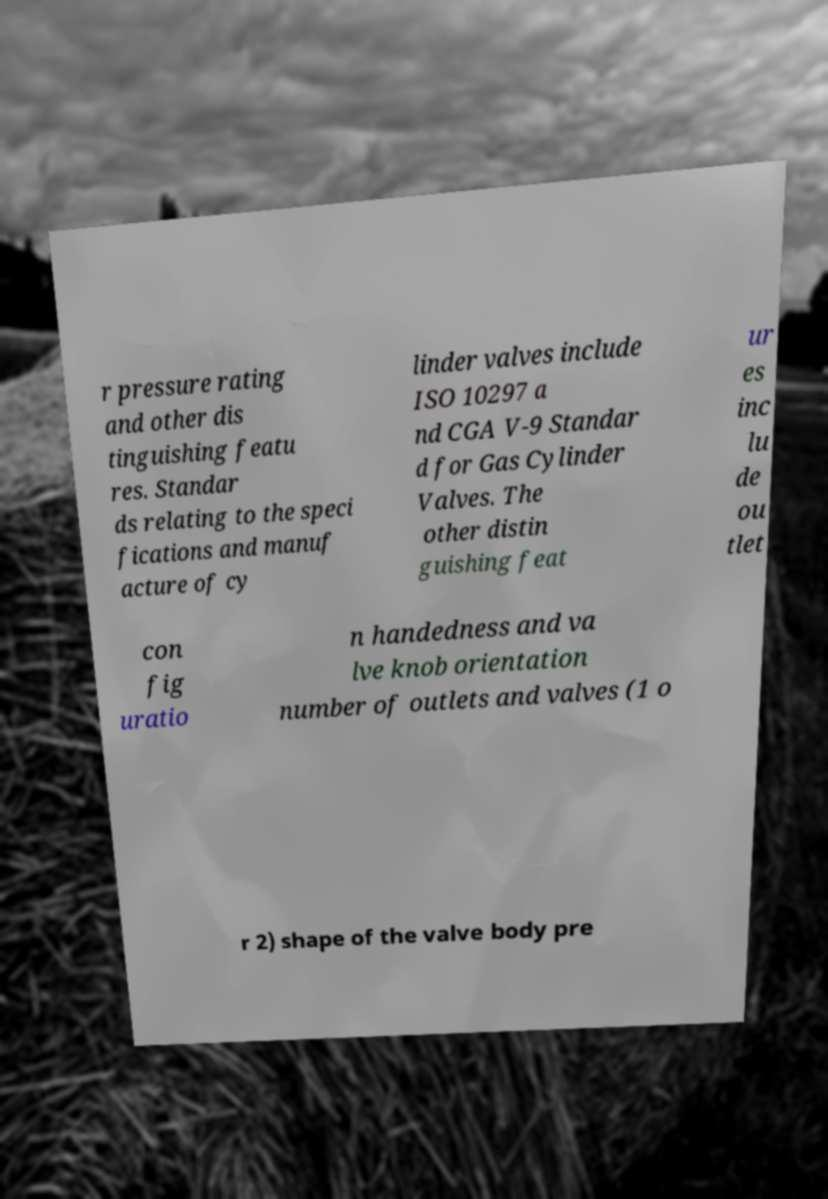Could you assist in decoding the text presented in this image and type it out clearly? r pressure rating and other dis tinguishing featu res. Standar ds relating to the speci fications and manuf acture of cy linder valves include ISO 10297 a nd CGA V-9 Standar d for Gas Cylinder Valves. The other distin guishing feat ur es inc lu de ou tlet con fig uratio n handedness and va lve knob orientation number of outlets and valves (1 o r 2) shape of the valve body pre 